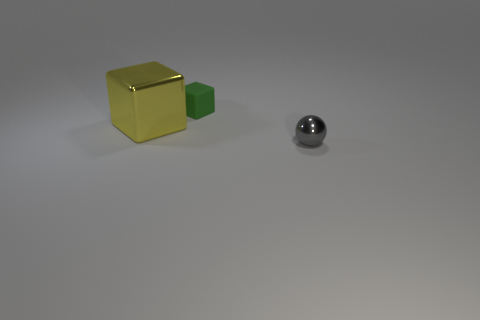Add 3 big red things. How many objects exist? 6 Subtract all spheres. How many objects are left? 2 Subtract all cyan blocks. Subtract all small green objects. How many objects are left? 2 Add 2 small gray shiny balls. How many small gray shiny balls are left? 3 Add 1 green objects. How many green objects exist? 2 Subtract 1 green cubes. How many objects are left? 2 